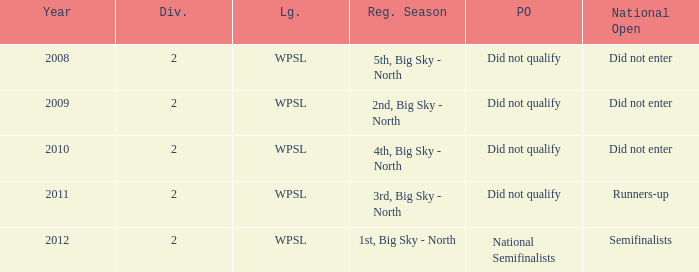What is the highest number of divisions mentioned? 2.0. 